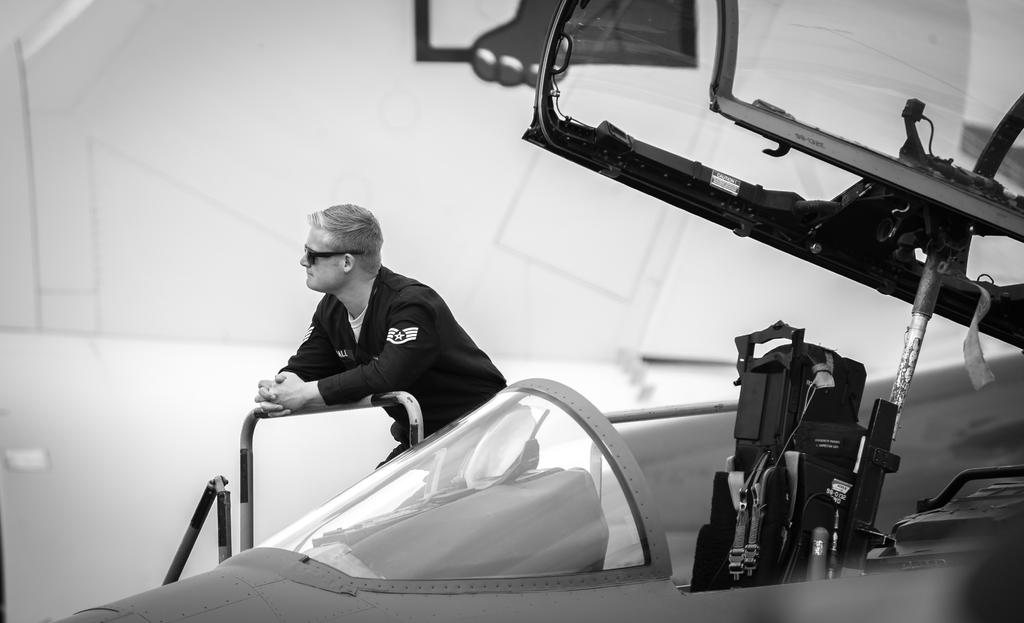What is the color scheme of the image? The image is black and white. What is the main subject in the image? There is an aeroplane in the image. Can you describe the person in the image? There is a person standing in the image, and they are wearing goggles. How many cherries can be seen hanging from the aeroplane in the image? There are no cherries present in the image, and therefore no such activity can be observed. 